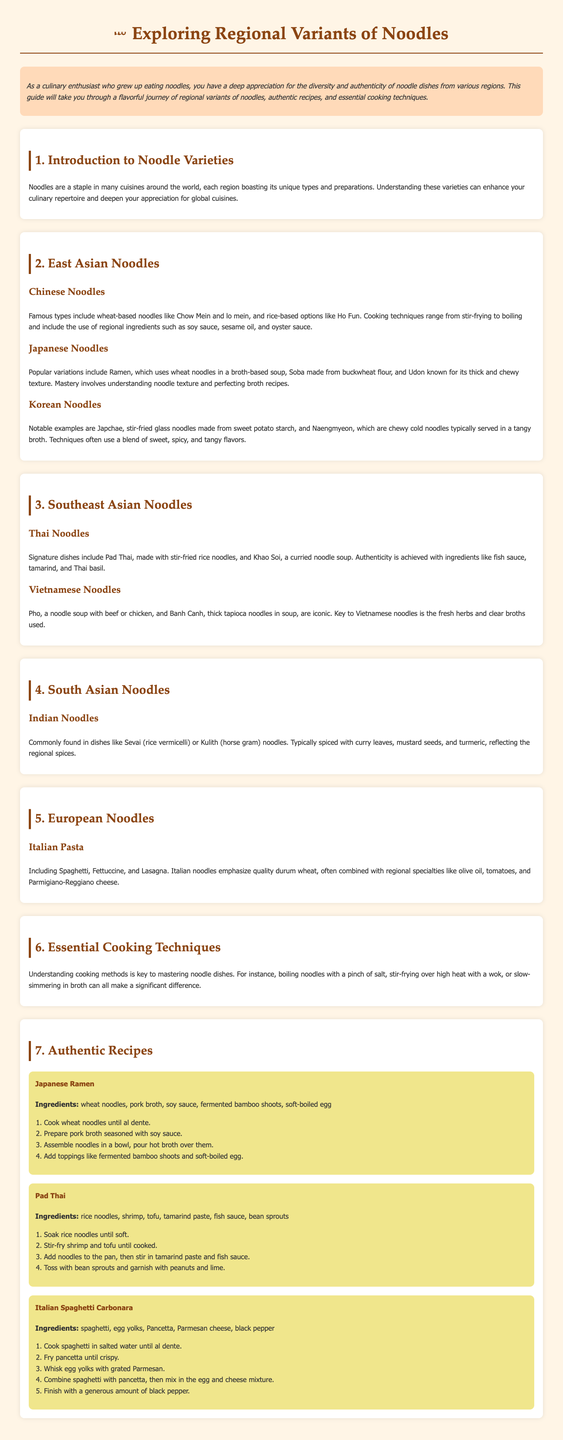What are the three notable examples of Korean noodles? The document lists Japchae, stir-fried glass noodles, and Naengmyeon, chewy cold noodles.
Answer: Japchae and Naengmyeon What is the primary ingredient in Japanese ramen? The guide states that ramen primarily uses wheat noodles along with pork broth.
Answer: Wheat noodles Name a key ingredient for authentic Pad Thai. The recipe for Pad Thai mentions tamarind paste as an essential ingredient.
Answer: Tamarind paste Which region's noodles emphasize quality durum wheat? The document specifies that Italian pasta emphasizes quality durum wheat.
Answer: Italian How are Japanese noodles typically seasoned? The guide mentions that mastering Japanese noodles involves understanding noodle texture and perfecting broth recipes, indicating seasoning is key.
Answer: Broth recipes What cooking technique is essential for spaghetti carbonara? The ingredients and steps for spaghetti carbonara highlight cooking spaghetti in salted water until al dente.
Answer: Cook in salted water List one cooking method described for Asian noodles. The document describes various techniques, including stir-frying and boiling for Asian noodles.
Answer: Stir-frying What is the total number of regional noodle categories discussed? The user guide discusses 6 categories: East Asian, Southeast Asian, South Asian, and European noodles.
Answer: 6 What dish uses thick tapioca noodles? The guide mentions Banh Canh as a dish that utilizes thick tapioca noodles.
Answer: Banh Canh 